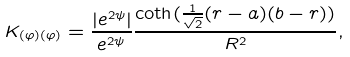<formula> <loc_0><loc_0><loc_500><loc_500>K _ { ( \varphi ) ( \varphi ) } = \frac { | e ^ { 2 \psi } | } { e ^ { 2 \psi } } \frac { \coth ( \frac { 1 } { \sqrt { 2 } } ( r - a ) ( b - r ) ) } { R ^ { 2 } } ,</formula> 